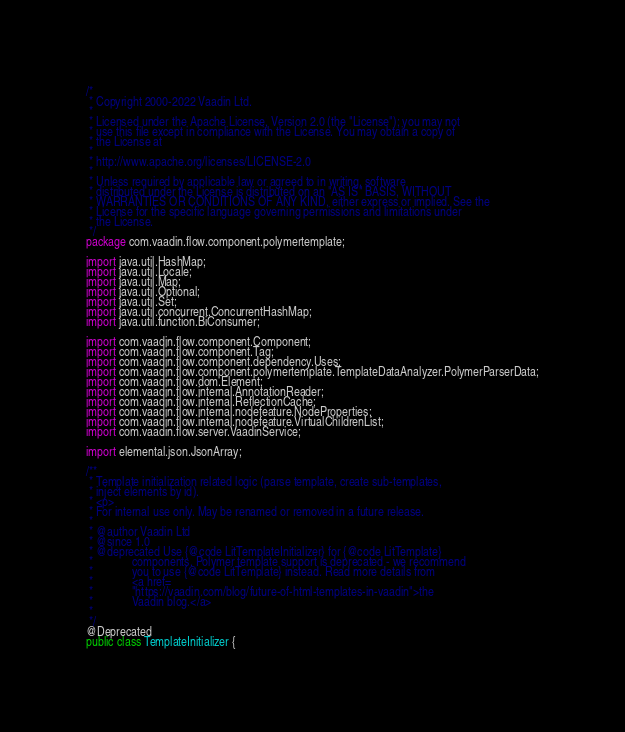<code> <loc_0><loc_0><loc_500><loc_500><_Java_>/*
 * Copyright 2000-2022 Vaadin Ltd.
 *
 * Licensed under the Apache License, Version 2.0 (the "License"); you may not
 * use this file except in compliance with the License. You may obtain a copy of
 * the License at
 *
 * http://www.apache.org/licenses/LICENSE-2.0
 *
 * Unless required by applicable law or agreed to in writing, software
 * distributed under the License is distributed on an "AS IS" BASIS, WITHOUT
 * WARRANTIES OR CONDITIONS OF ANY KIND, either express or implied. See the
 * License for the specific language governing permissions and limitations under
 * the License.
 */
package com.vaadin.flow.component.polymertemplate;

import java.util.HashMap;
import java.util.Locale;
import java.util.Map;
import java.util.Optional;
import java.util.Set;
import java.util.concurrent.ConcurrentHashMap;
import java.util.function.BiConsumer;

import com.vaadin.flow.component.Component;
import com.vaadin.flow.component.Tag;
import com.vaadin.flow.component.dependency.Uses;
import com.vaadin.flow.component.polymertemplate.TemplateDataAnalyzer.PolymerParserData;
import com.vaadin.flow.dom.Element;
import com.vaadin.flow.internal.AnnotationReader;
import com.vaadin.flow.internal.ReflectionCache;
import com.vaadin.flow.internal.nodefeature.NodeProperties;
import com.vaadin.flow.internal.nodefeature.VirtualChildrenList;
import com.vaadin.flow.server.VaadinService;

import elemental.json.JsonArray;

/**
 * Template initialization related logic (parse template, create sub-templates,
 * inject elements by id).
 * <p>
 * For internal use only. May be renamed or removed in a future release.
 *
 * @author Vaadin Ltd
 * @since 1.0
 * @deprecated Use {@code LitTemplateInitializer} for {@code LitTemplate}
 *             components. Polymer template support is deprecated - we recommend
 *             you to use {@code LitTemplate} instead. Read more details from
 *             <a href=
 *             "https://vaadin.com/blog/future-of-html-templates-in-vaadin">the
 *             Vaadin blog.</a>
 *
 */
@Deprecated
public class TemplateInitializer {</code> 